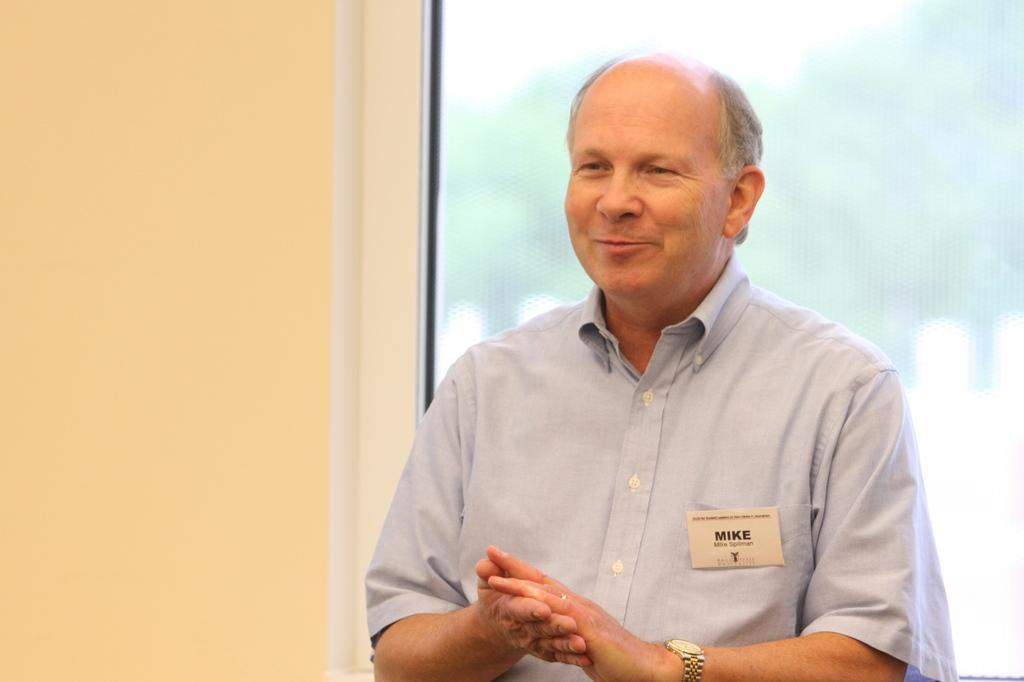Please provide a concise description of this image. In this image we can see a person, there is a card on his pocket with some text on it, also we can see the wall, and the window. 